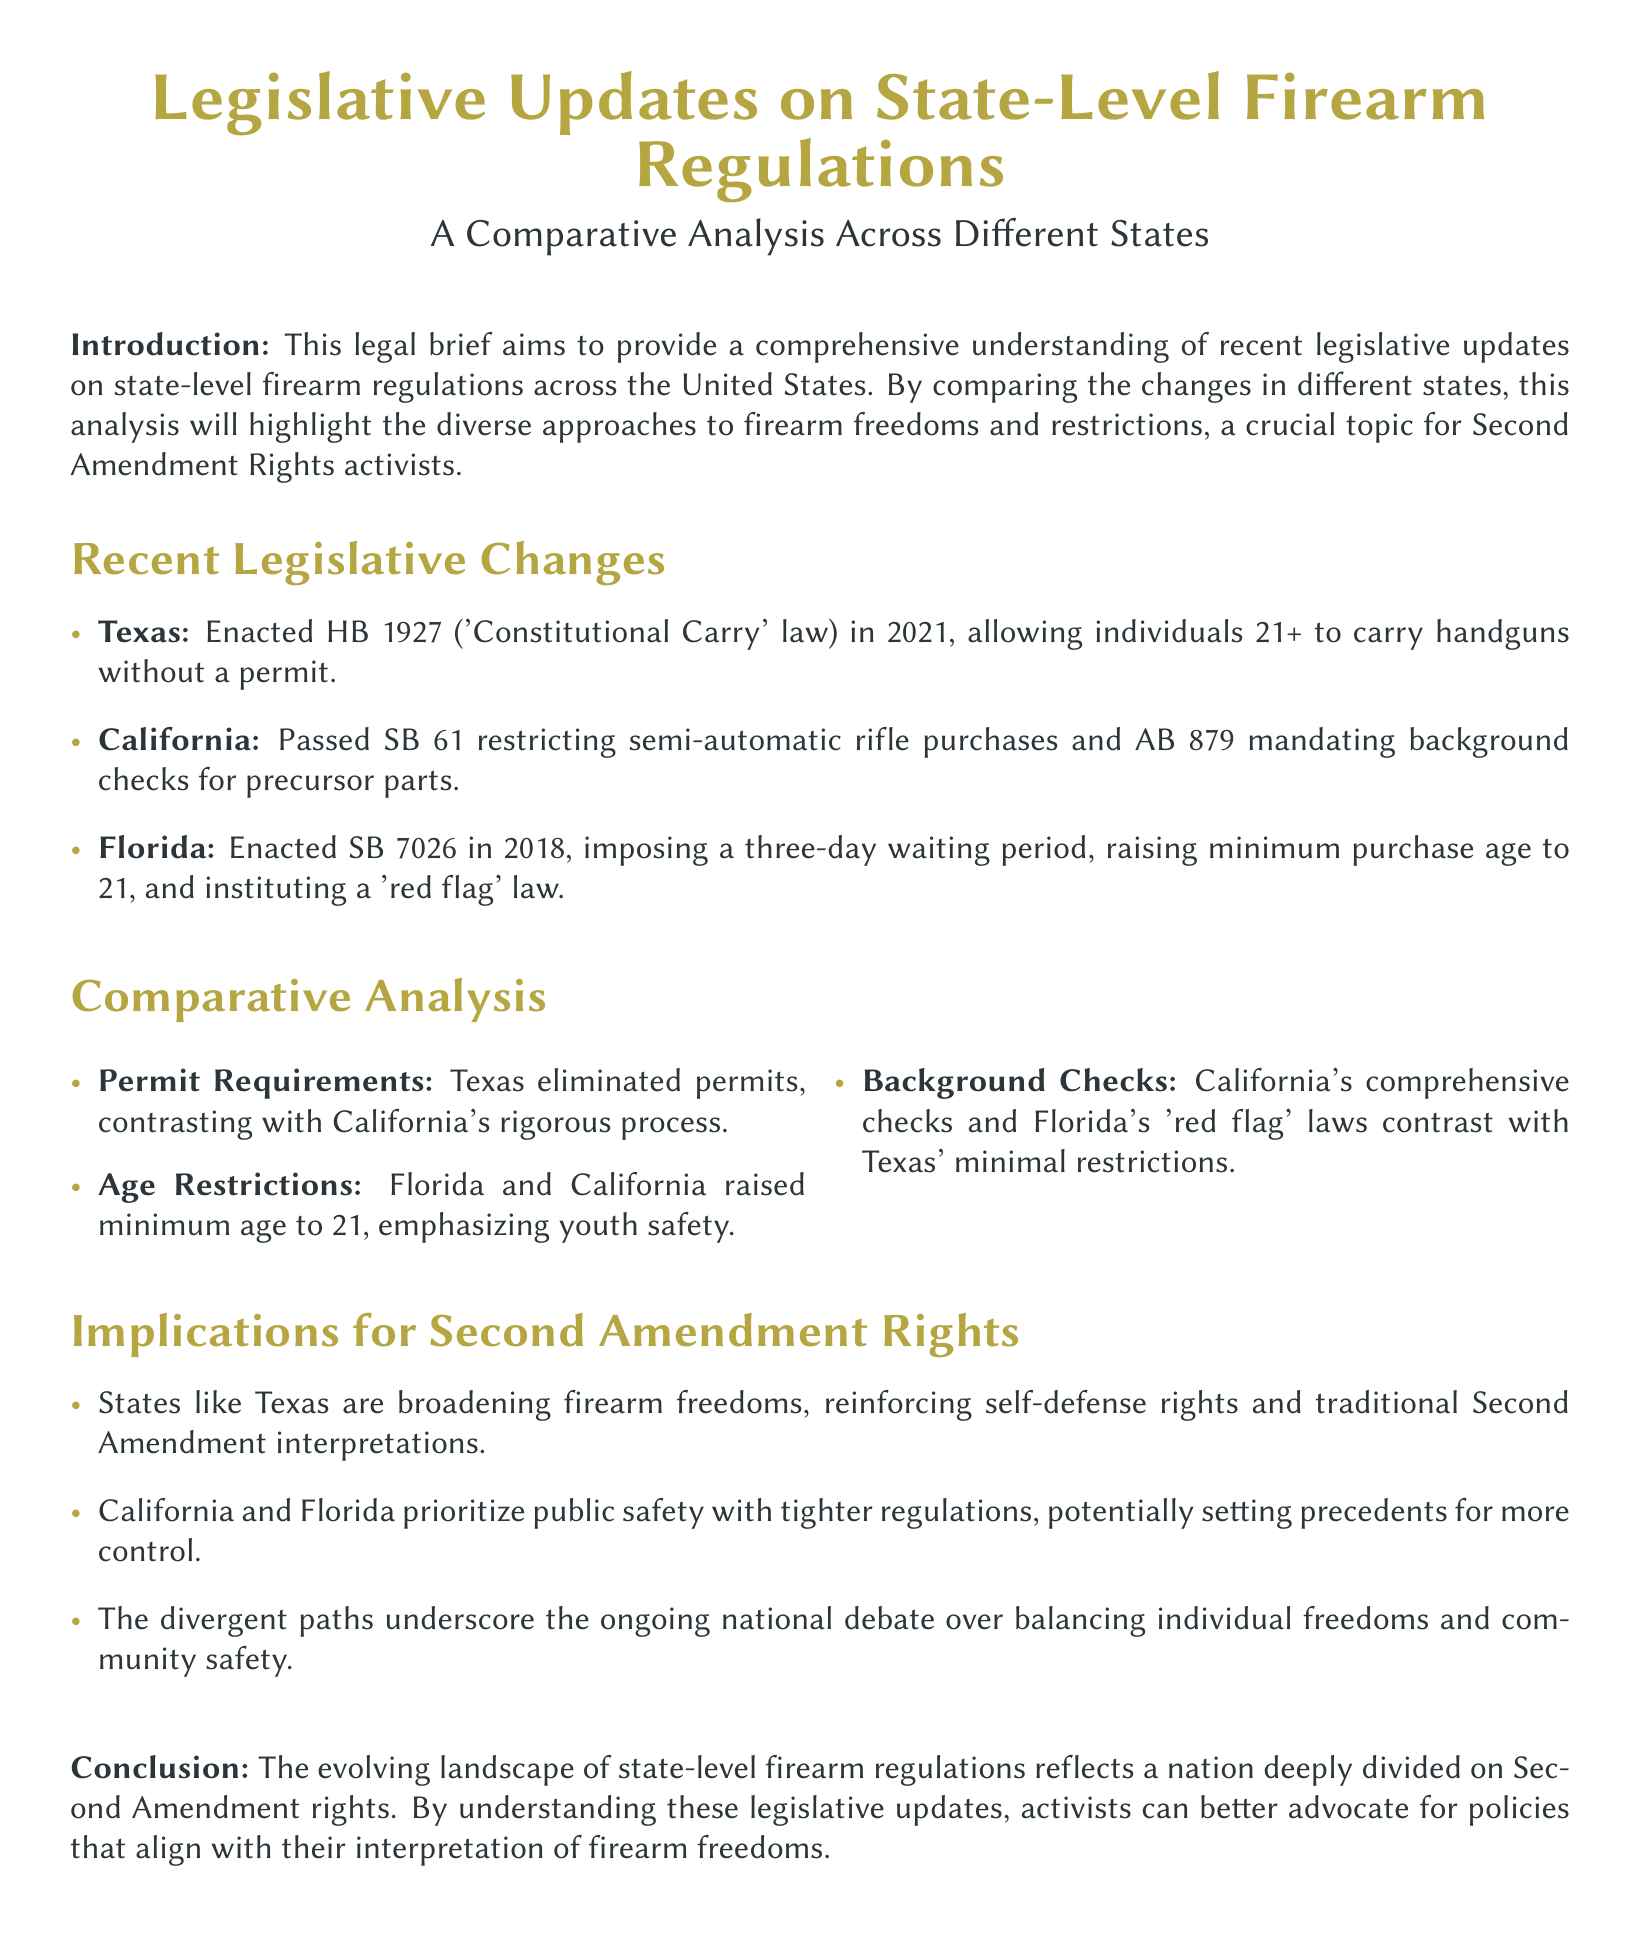What law did Texas enact in 2021? Texas enacted HB 1927, known as the 'Constitutional Carry' law, in 2021.
Answer: HB 1927 What does California's AB 879 mandate? California's AB 879 mandates background checks for precursor parts.
Answer: Background checks What is the minimum age to purchase firearms in Florida? Florida raised the minimum purchase age for firearms to 21.
Answer: 21 How does Texas's permit requirement compare to California's? Texas eliminated permits, while California has a rigorous permit process.
Answer: Eliminated permits Which state has enacted 'red flag' laws? Florida has instituted 'red flag' laws.
Answer: Florida What legislative approach does Texas represent regarding firearm freedoms? Texas is broadening firearm freedoms, reinforcing self-defense rights.
Answer: Broadening firearm freedoms What type of law did California pass regarding semi-automatic rifles? California passed SB 61, which restricts semi-automatic rifle purchases.
Answer: SB 61 How do California and Florida's regulations emphasize public safety? They have tightened regulations compared to Texas, which has minimal restrictions.
Answer: Tightened regulations What does the document highlight about the national debate on firearm regulations? The document underscores the debate over balancing individual freedoms and community safety.
Answer: Balancing individual freedoms and community safety 